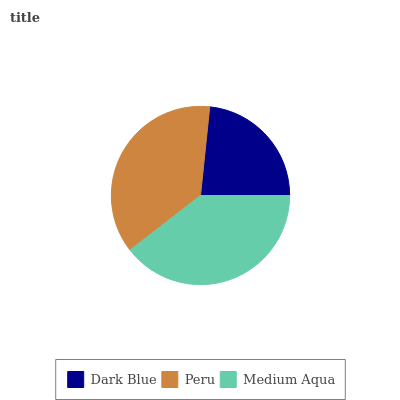Is Dark Blue the minimum?
Answer yes or no. Yes. Is Medium Aqua the maximum?
Answer yes or no. Yes. Is Peru the minimum?
Answer yes or no. No. Is Peru the maximum?
Answer yes or no. No. Is Peru greater than Dark Blue?
Answer yes or no. Yes. Is Dark Blue less than Peru?
Answer yes or no. Yes. Is Dark Blue greater than Peru?
Answer yes or no. No. Is Peru less than Dark Blue?
Answer yes or no. No. Is Peru the high median?
Answer yes or no. Yes. Is Peru the low median?
Answer yes or no. Yes. Is Medium Aqua the high median?
Answer yes or no. No. Is Medium Aqua the low median?
Answer yes or no. No. 